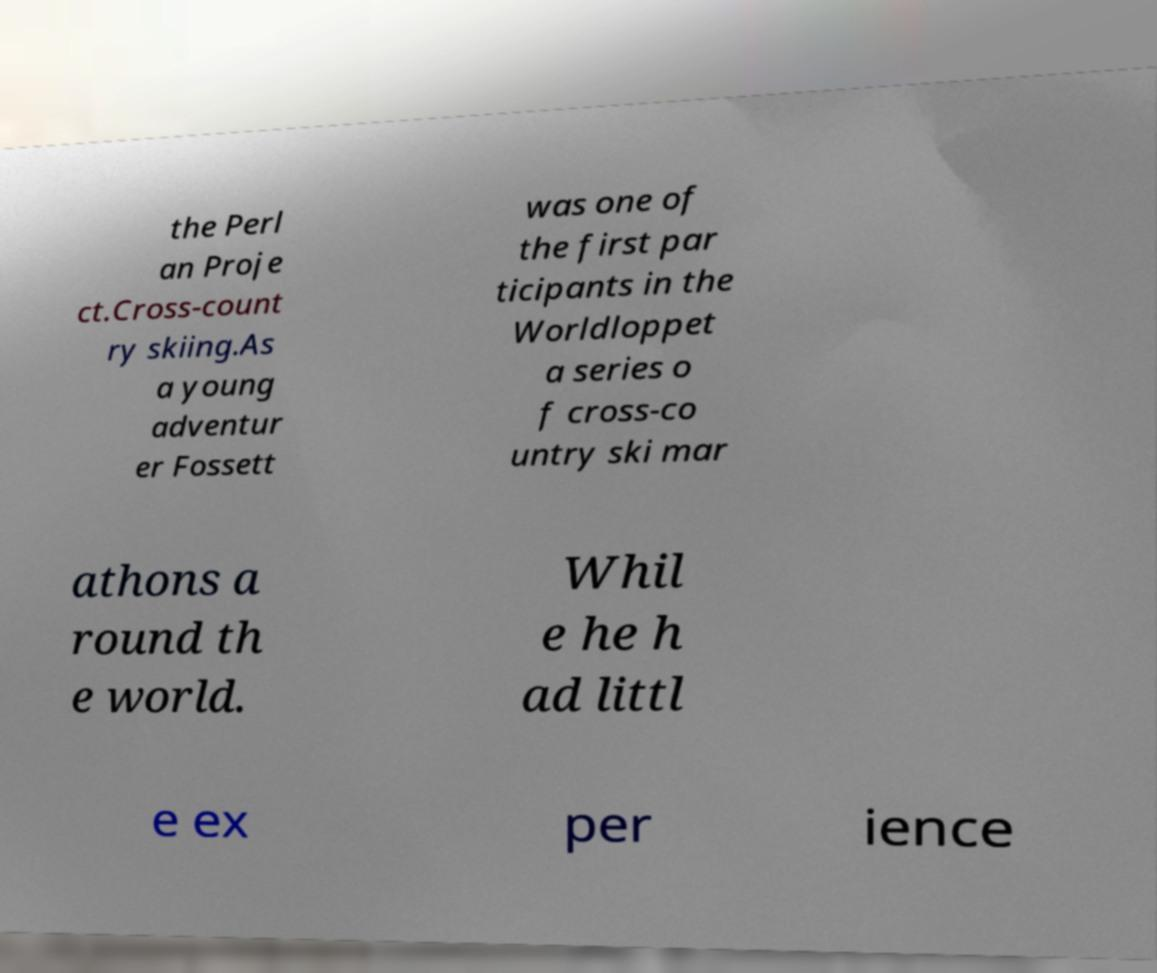Could you assist in decoding the text presented in this image and type it out clearly? the Perl an Proje ct.Cross-count ry skiing.As a young adventur er Fossett was one of the first par ticipants in the Worldloppet a series o f cross-co untry ski mar athons a round th e world. Whil e he h ad littl e ex per ience 